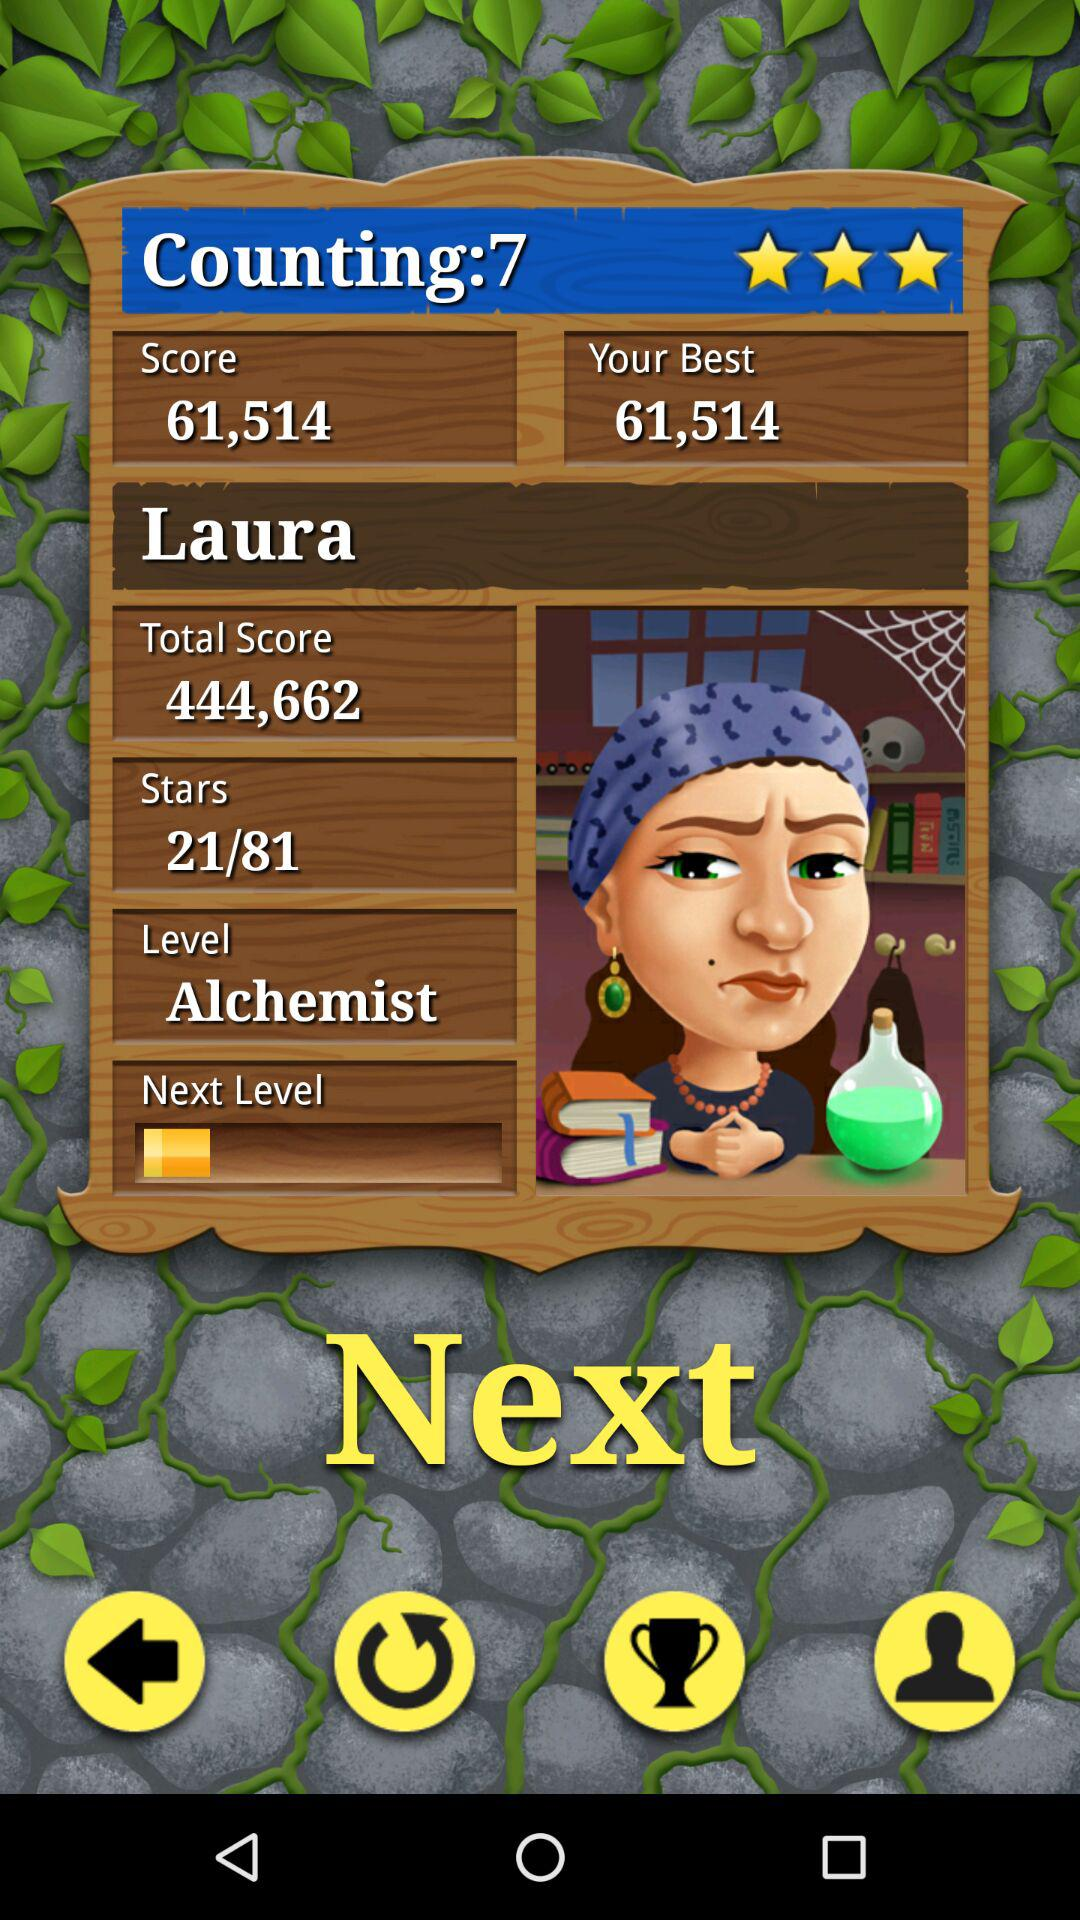What is the name? The name is Laura. 